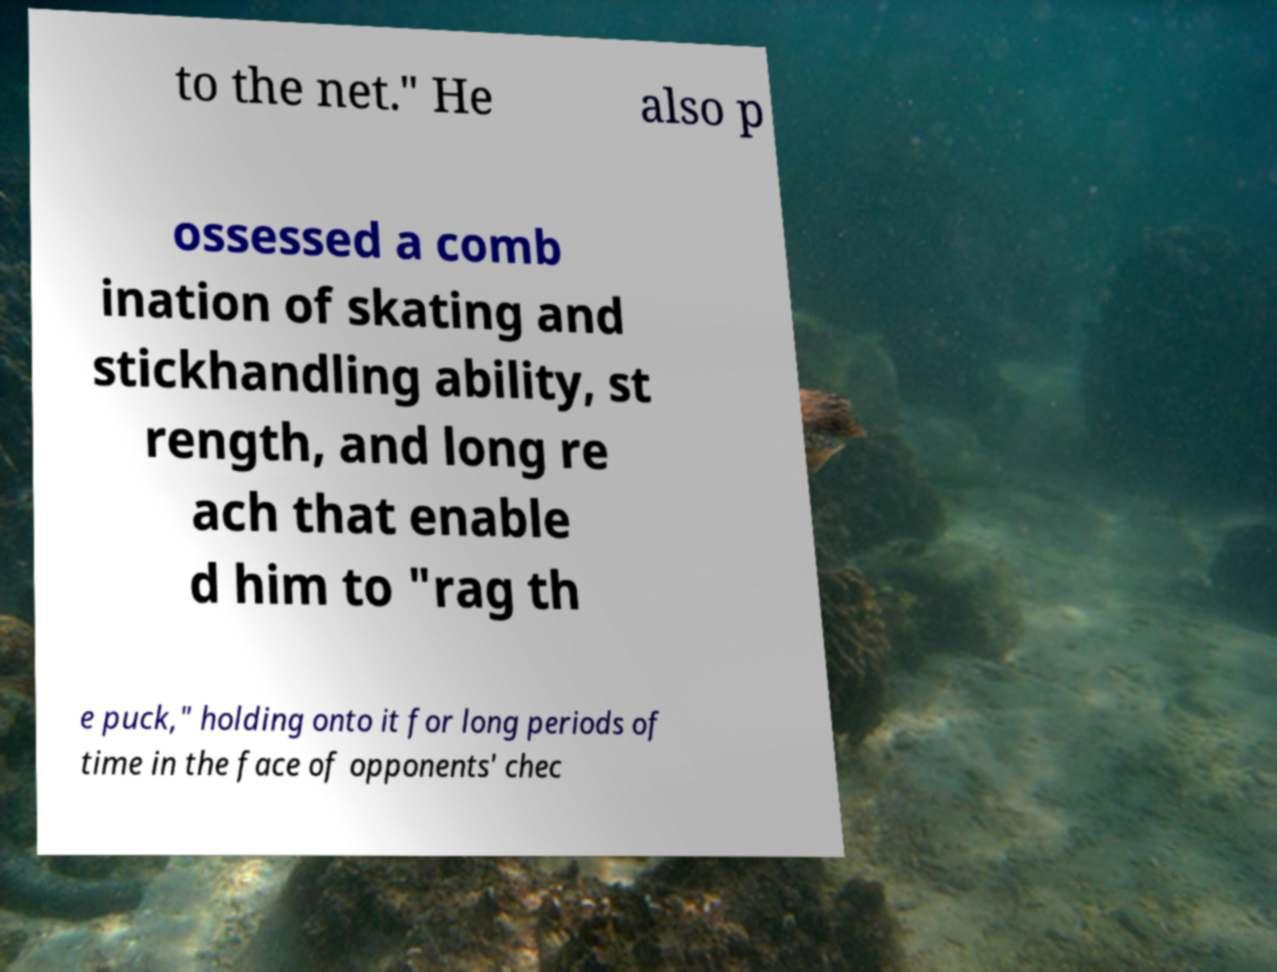What messages or text are displayed in this image? I need them in a readable, typed format. to the net." He also p ossessed a comb ination of skating and stickhandling ability, st rength, and long re ach that enable d him to "rag th e puck," holding onto it for long periods of time in the face of opponents' chec 